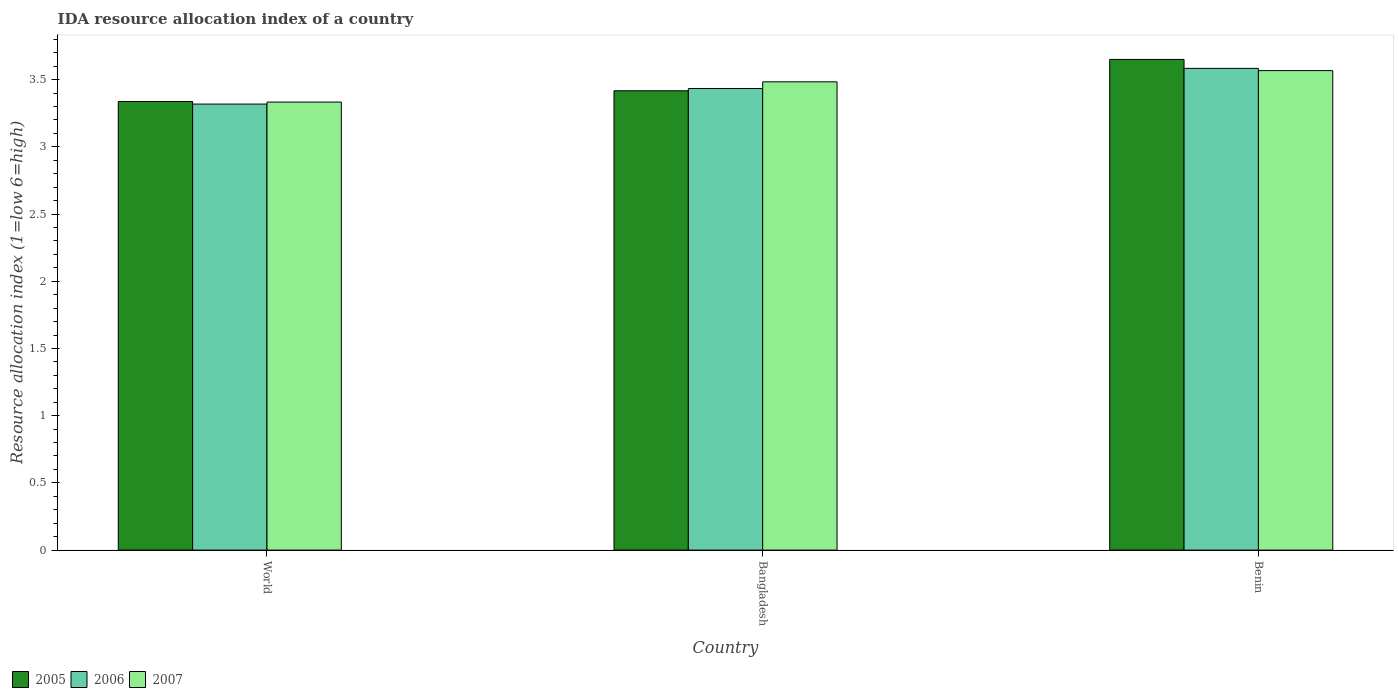How many different coloured bars are there?
Provide a short and direct response. 3. How many bars are there on the 1st tick from the right?
Provide a succinct answer. 3. What is the label of the 2nd group of bars from the left?
Keep it short and to the point. Bangladesh. In how many cases, is the number of bars for a given country not equal to the number of legend labels?
Your answer should be compact. 0. What is the IDA resource allocation index in 2007 in World?
Your response must be concise. 3.33. Across all countries, what is the maximum IDA resource allocation index in 2007?
Your response must be concise. 3.57. Across all countries, what is the minimum IDA resource allocation index in 2006?
Ensure brevity in your answer.  3.32. In which country was the IDA resource allocation index in 2005 maximum?
Provide a succinct answer. Benin. In which country was the IDA resource allocation index in 2005 minimum?
Provide a short and direct response. World. What is the total IDA resource allocation index in 2006 in the graph?
Offer a terse response. 10.33. What is the difference between the IDA resource allocation index in 2007 in Bangladesh and that in Benin?
Your response must be concise. -0.08. What is the difference between the IDA resource allocation index in 2005 in Bangladesh and the IDA resource allocation index in 2007 in World?
Ensure brevity in your answer.  0.08. What is the average IDA resource allocation index in 2007 per country?
Offer a very short reply. 3.46. What is the difference between the IDA resource allocation index of/in 2007 and IDA resource allocation index of/in 2005 in World?
Your answer should be very brief. -0. What is the ratio of the IDA resource allocation index in 2005 in Benin to that in World?
Give a very brief answer. 1.09. Is the IDA resource allocation index in 2007 in Benin less than that in World?
Give a very brief answer. No. Is the difference between the IDA resource allocation index in 2007 in Benin and World greater than the difference between the IDA resource allocation index in 2005 in Benin and World?
Offer a very short reply. No. What is the difference between the highest and the second highest IDA resource allocation index in 2005?
Provide a short and direct response. -0.23. What is the difference between the highest and the lowest IDA resource allocation index in 2006?
Your answer should be very brief. 0.27. Is the sum of the IDA resource allocation index in 2005 in Bangladesh and World greater than the maximum IDA resource allocation index in 2007 across all countries?
Your answer should be compact. Yes. What does the 2nd bar from the right in World represents?
Offer a very short reply. 2006. Is it the case that in every country, the sum of the IDA resource allocation index in 2007 and IDA resource allocation index in 2005 is greater than the IDA resource allocation index in 2006?
Give a very brief answer. Yes. How many countries are there in the graph?
Offer a very short reply. 3. Are the values on the major ticks of Y-axis written in scientific E-notation?
Make the answer very short. No. Does the graph contain any zero values?
Ensure brevity in your answer.  No. Does the graph contain grids?
Your answer should be compact. No. Where does the legend appear in the graph?
Offer a very short reply. Bottom left. How many legend labels are there?
Your response must be concise. 3. How are the legend labels stacked?
Provide a short and direct response. Horizontal. What is the title of the graph?
Keep it short and to the point. IDA resource allocation index of a country. What is the label or title of the Y-axis?
Offer a very short reply. Resource allocation index (1=low 6=high). What is the Resource allocation index (1=low 6=high) in 2005 in World?
Provide a succinct answer. 3.34. What is the Resource allocation index (1=low 6=high) in 2006 in World?
Provide a short and direct response. 3.32. What is the Resource allocation index (1=low 6=high) of 2007 in World?
Provide a succinct answer. 3.33. What is the Resource allocation index (1=low 6=high) in 2005 in Bangladesh?
Ensure brevity in your answer.  3.42. What is the Resource allocation index (1=low 6=high) of 2006 in Bangladesh?
Provide a succinct answer. 3.43. What is the Resource allocation index (1=low 6=high) of 2007 in Bangladesh?
Provide a short and direct response. 3.48. What is the Resource allocation index (1=low 6=high) of 2005 in Benin?
Your answer should be very brief. 3.65. What is the Resource allocation index (1=low 6=high) in 2006 in Benin?
Keep it short and to the point. 3.58. What is the Resource allocation index (1=low 6=high) of 2007 in Benin?
Offer a terse response. 3.57. Across all countries, what is the maximum Resource allocation index (1=low 6=high) of 2005?
Provide a short and direct response. 3.65. Across all countries, what is the maximum Resource allocation index (1=low 6=high) in 2006?
Make the answer very short. 3.58. Across all countries, what is the maximum Resource allocation index (1=low 6=high) of 2007?
Offer a very short reply. 3.57. Across all countries, what is the minimum Resource allocation index (1=low 6=high) in 2005?
Your answer should be compact. 3.34. Across all countries, what is the minimum Resource allocation index (1=low 6=high) of 2006?
Give a very brief answer. 3.32. Across all countries, what is the minimum Resource allocation index (1=low 6=high) in 2007?
Provide a short and direct response. 3.33. What is the total Resource allocation index (1=low 6=high) of 2005 in the graph?
Your answer should be compact. 10.4. What is the total Resource allocation index (1=low 6=high) of 2006 in the graph?
Your response must be concise. 10.33. What is the total Resource allocation index (1=low 6=high) in 2007 in the graph?
Ensure brevity in your answer.  10.38. What is the difference between the Resource allocation index (1=low 6=high) of 2005 in World and that in Bangladesh?
Offer a very short reply. -0.08. What is the difference between the Resource allocation index (1=low 6=high) of 2006 in World and that in Bangladesh?
Your answer should be very brief. -0.12. What is the difference between the Resource allocation index (1=low 6=high) of 2007 in World and that in Bangladesh?
Your response must be concise. -0.15. What is the difference between the Resource allocation index (1=low 6=high) of 2005 in World and that in Benin?
Give a very brief answer. -0.31. What is the difference between the Resource allocation index (1=low 6=high) in 2006 in World and that in Benin?
Keep it short and to the point. -0.27. What is the difference between the Resource allocation index (1=low 6=high) in 2007 in World and that in Benin?
Provide a short and direct response. -0.23. What is the difference between the Resource allocation index (1=low 6=high) in 2005 in Bangladesh and that in Benin?
Your answer should be compact. -0.23. What is the difference between the Resource allocation index (1=low 6=high) of 2007 in Bangladesh and that in Benin?
Give a very brief answer. -0.08. What is the difference between the Resource allocation index (1=low 6=high) in 2005 in World and the Resource allocation index (1=low 6=high) in 2006 in Bangladesh?
Provide a short and direct response. -0.1. What is the difference between the Resource allocation index (1=low 6=high) of 2005 in World and the Resource allocation index (1=low 6=high) of 2007 in Bangladesh?
Keep it short and to the point. -0.15. What is the difference between the Resource allocation index (1=low 6=high) of 2006 in World and the Resource allocation index (1=low 6=high) of 2007 in Bangladesh?
Your answer should be compact. -0.17. What is the difference between the Resource allocation index (1=low 6=high) in 2005 in World and the Resource allocation index (1=low 6=high) in 2006 in Benin?
Provide a short and direct response. -0.25. What is the difference between the Resource allocation index (1=low 6=high) of 2005 in World and the Resource allocation index (1=low 6=high) of 2007 in Benin?
Keep it short and to the point. -0.23. What is the difference between the Resource allocation index (1=low 6=high) of 2006 in World and the Resource allocation index (1=low 6=high) of 2007 in Benin?
Your answer should be very brief. -0.25. What is the difference between the Resource allocation index (1=low 6=high) in 2005 in Bangladesh and the Resource allocation index (1=low 6=high) in 2007 in Benin?
Your answer should be compact. -0.15. What is the difference between the Resource allocation index (1=low 6=high) of 2006 in Bangladesh and the Resource allocation index (1=low 6=high) of 2007 in Benin?
Offer a very short reply. -0.13. What is the average Resource allocation index (1=low 6=high) of 2005 per country?
Offer a terse response. 3.47. What is the average Resource allocation index (1=low 6=high) of 2006 per country?
Provide a short and direct response. 3.44. What is the average Resource allocation index (1=low 6=high) in 2007 per country?
Your answer should be very brief. 3.46. What is the difference between the Resource allocation index (1=low 6=high) of 2005 and Resource allocation index (1=low 6=high) of 2006 in World?
Offer a very short reply. 0.02. What is the difference between the Resource allocation index (1=low 6=high) of 2005 and Resource allocation index (1=low 6=high) of 2007 in World?
Provide a short and direct response. 0. What is the difference between the Resource allocation index (1=low 6=high) in 2006 and Resource allocation index (1=low 6=high) in 2007 in World?
Offer a very short reply. -0.01. What is the difference between the Resource allocation index (1=low 6=high) of 2005 and Resource allocation index (1=low 6=high) of 2006 in Bangladesh?
Provide a succinct answer. -0.02. What is the difference between the Resource allocation index (1=low 6=high) in 2005 and Resource allocation index (1=low 6=high) in 2007 in Bangladesh?
Your answer should be very brief. -0.07. What is the difference between the Resource allocation index (1=low 6=high) in 2006 and Resource allocation index (1=low 6=high) in 2007 in Bangladesh?
Offer a very short reply. -0.05. What is the difference between the Resource allocation index (1=low 6=high) in 2005 and Resource allocation index (1=low 6=high) in 2006 in Benin?
Ensure brevity in your answer.  0.07. What is the difference between the Resource allocation index (1=low 6=high) in 2005 and Resource allocation index (1=low 6=high) in 2007 in Benin?
Offer a terse response. 0.08. What is the difference between the Resource allocation index (1=low 6=high) in 2006 and Resource allocation index (1=low 6=high) in 2007 in Benin?
Ensure brevity in your answer.  0.02. What is the ratio of the Resource allocation index (1=low 6=high) of 2005 in World to that in Bangladesh?
Offer a very short reply. 0.98. What is the ratio of the Resource allocation index (1=low 6=high) of 2006 in World to that in Bangladesh?
Give a very brief answer. 0.97. What is the ratio of the Resource allocation index (1=low 6=high) of 2007 in World to that in Bangladesh?
Provide a short and direct response. 0.96. What is the ratio of the Resource allocation index (1=low 6=high) in 2005 in World to that in Benin?
Provide a succinct answer. 0.91. What is the ratio of the Resource allocation index (1=low 6=high) in 2006 in World to that in Benin?
Keep it short and to the point. 0.93. What is the ratio of the Resource allocation index (1=low 6=high) in 2007 in World to that in Benin?
Your answer should be compact. 0.93. What is the ratio of the Resource allocation index (1=low 6=high) in 2005 in Bangladesh to that in Benin?
Keep it short and to the point. 0.94. What is the ratio of the Resource allocation index (1=low 6=high) in 2006 in Bangladesh to that in Benin?
Ensure brevity in your answer.  0.96. What is the ratio of the Resource allocation index (1=low 6=high) of 2007 in Bangladesh to that in Benin?
Give a very brief answer. 0.98. What is the difference between the highest and the second highest Resource allocation index (1=low 6=high) of 2005?
Your answer should be compact. 0.23. What is the difference between the highest and the second highest Resource allocation index (1=low 6=high) of 2007?
Provide a short and direct response. 0.08. What is the difference between the highest and the lowest Resource allocation index (1=low 6=high) in 2005?
Make the answer very short. 0.31. What is the difference between the highest and the lowest Resource allocation index (1=low 6=high) of 2006?
Your response must be concise. 0.27. What is the difference between the highest and the lowest Resource allocation index (1=low 6=high) in 2007?
Your answer should be compact. 0.23. 